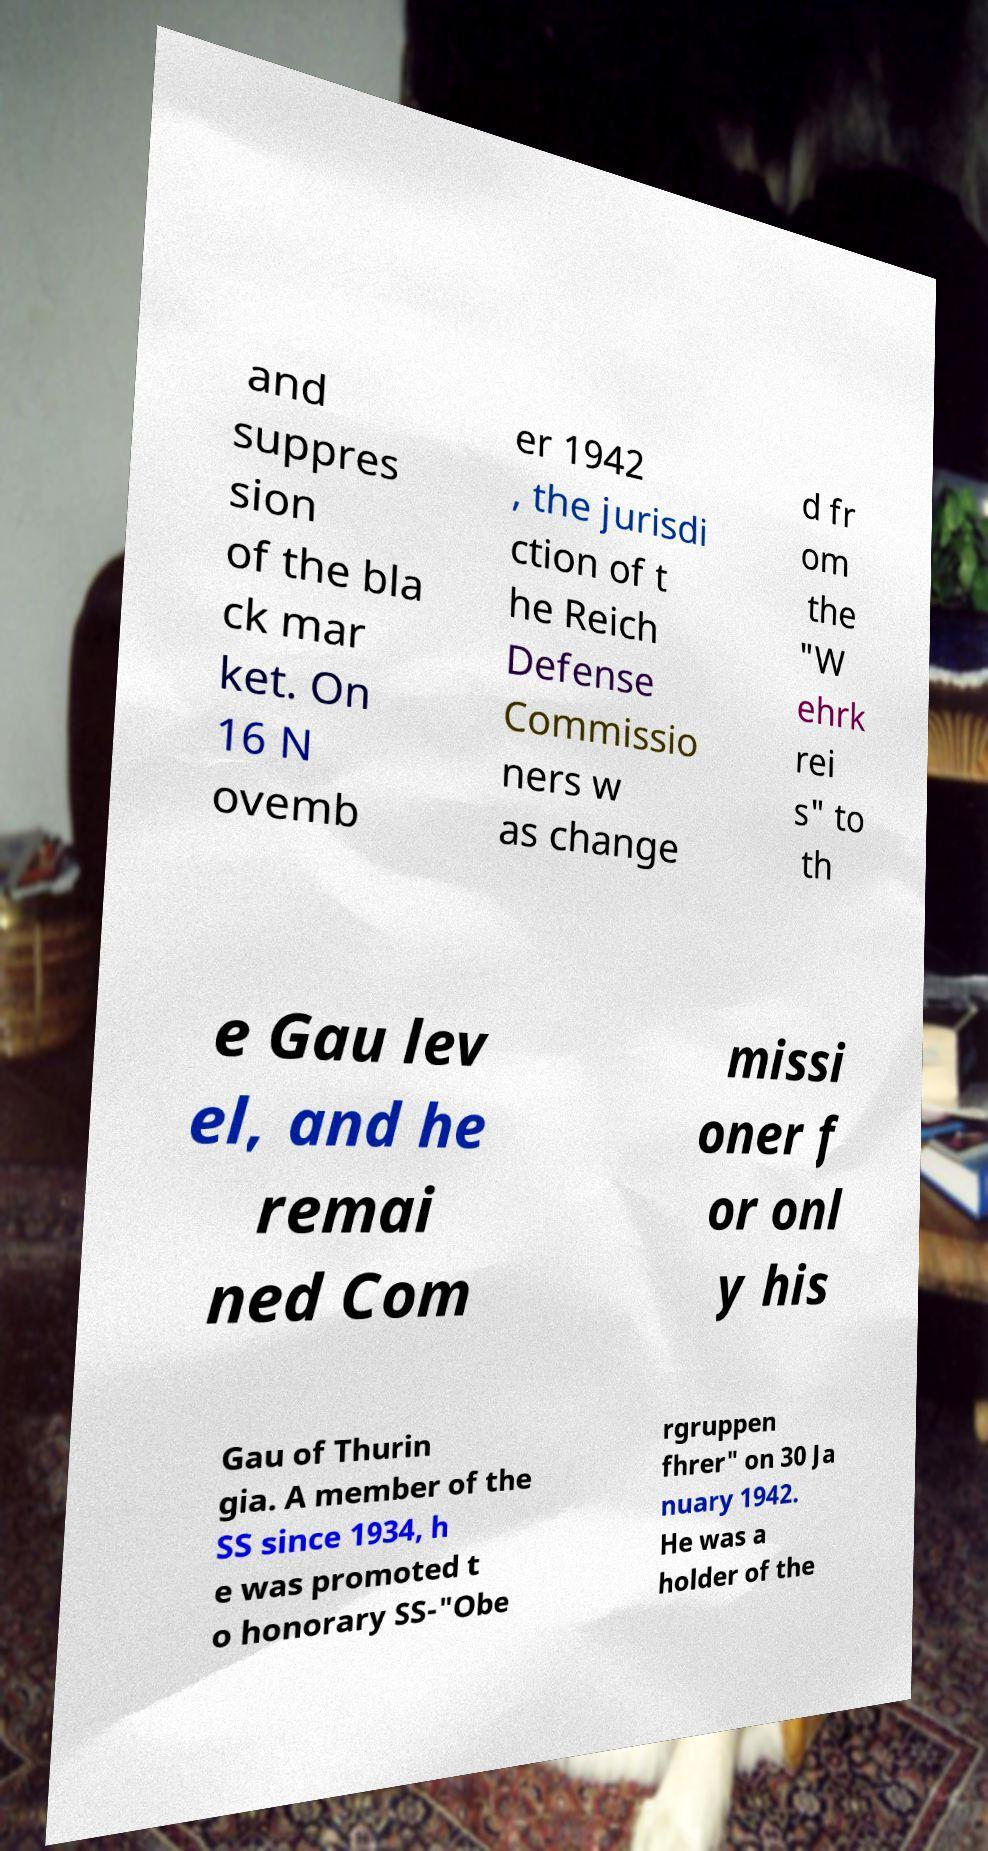I need the written content from this picture converted into text. Can you do that? and suppres sion of the bla ck mar ket. On 16 N ovemb er 1942 , the jurisdi ction of t he Reich Defense Commissio ners w as change d fr om the "W ehrk rei s" to th e Gau lev el, and he remai ned Com missi oner f or onl y his Gau of Thurin gia. A member of the SS since 1934, h e was promoted t o honorary SS-"Obe rgruppen fhrer" on 30 Ja nuary 1942. He was a holder of the 